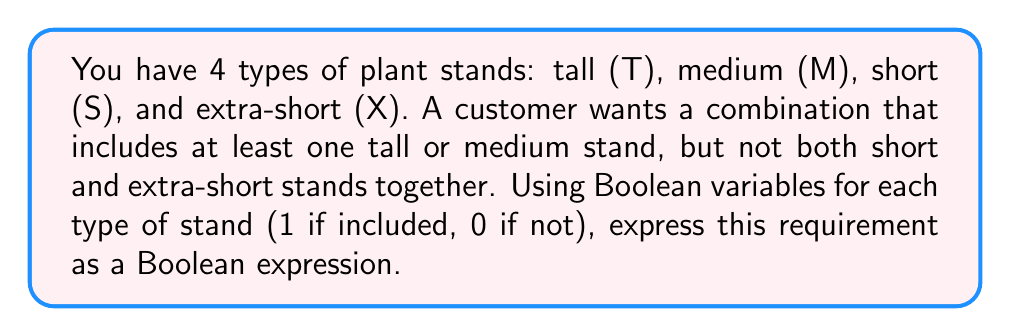Provide a solution to this math problem. Let's approach this step-by-step:

1) Define Boolean variables:
   T = Tall stand
   M = Medium stand
   S = Short stand
   X = Extra-short stand

2) Break down the requirements:
   a) At least one tall or medium stand: $(T \lor M)$
   b) Not both short and extra-short stands: $\lnot(S \land X)$

3) Combine these conditions using AND ($\land$):
   $$(T \lor M) \land \lnot(S \land X)$$

4) Expand $\lnot(S \land X)$ using De Morgan's Law:
   $\lnot(S \land X) = \lnot S \lor \lnot X$

5) Substitute this back into our expression:
   $$(T \lor M) \land (\lnot S \lor \lnot X)$$

This Boolean expression represents the optimal arrangement of plant stands based on the customer's requirements. It will evaluate to 1 (true) for valid combinations and 0 (false) for invalid ones.
Answer: $(T \lor M) \land (\lnot S \lor \lnot X)$ 